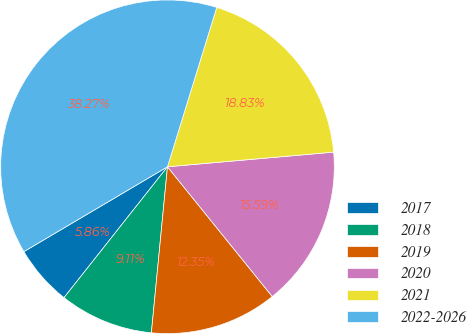Convert chart to OTSL. <chart><loc_0><loc_0><loc_500><loc_500><pie_chart><fcel>2017<fcel>2018<fcel>2019<fcel>2020<fcel>2021<fcel>2022-2026<nl><fcel>5.86%<fcel>9.11%<fcel>12.35%<fcel>15.59%<fcel>18.83%<fcel>38.27%<nl></chart> 